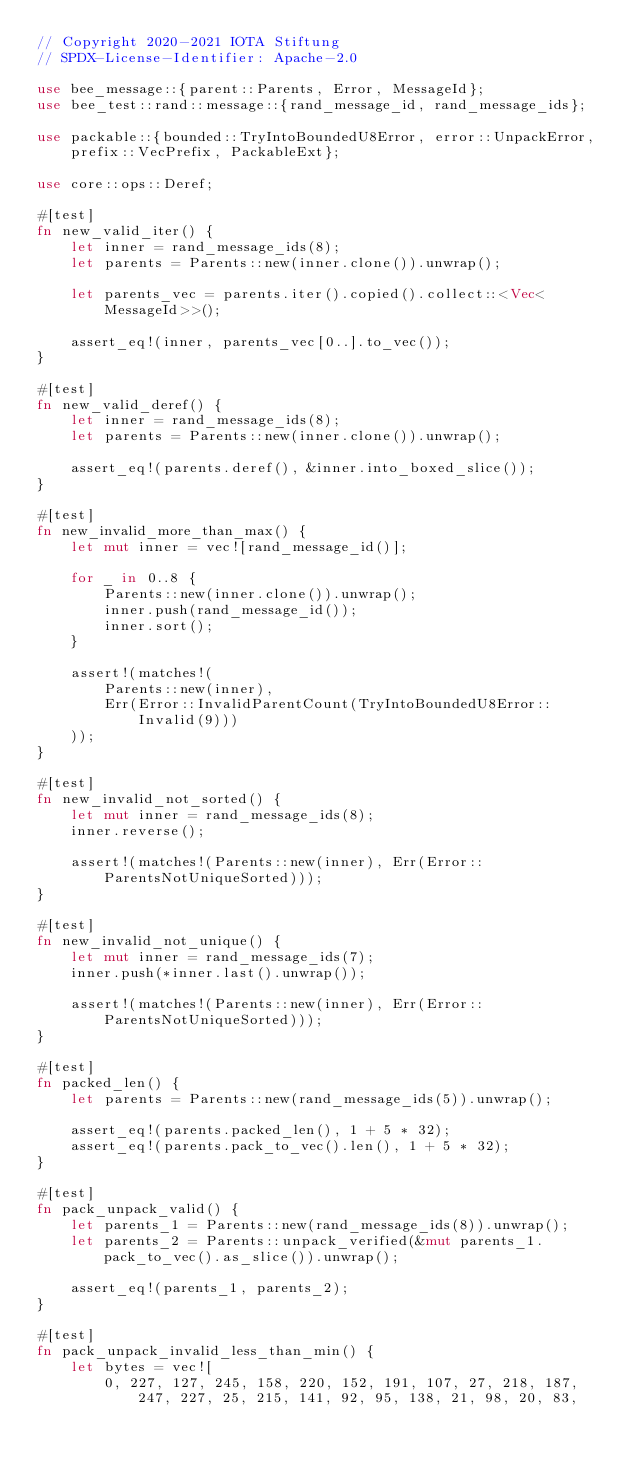<code> <loc_0><loc_0><loc_500><loc_500><_Rust_>// Copyright 2020-2021 IOTA Stiftung
// SPDX-License-Identifier: Apache-2.0

use bee_message::{parent::Parents, Error, MessageId};
use bee_test::rand::message::{rand_message_id, rand_message_ids};

use packable::{bounded::TryIntoBoundedU8Error, error::UnpackError, prefix::VecPrefix, PackableExt};

use core::ops::Deref;

#[test]
fn new_valid_iter() {
    let inner = rand_message_ids(8);
    let parents = Parents::new(inner.clone()).unwrap();

    let parents_vec = parents.iter().copied().collect::<Vec<MessageId>>();

    assert_eq!(inner, parents_vec[0..].to_vec());
}

#[test]
fn new_valid_deref() {
    let inner = rand_message_ids(8);
    let parents = Parents::new(inner.clone()).unwrap();

    assert_eq!(parents.deref(), &inner.into_boxed_slice());
}

#[test]
fn new_invalid_more_than_max() {
    let mut inner = vec![rand_message_id()];

    for _ in 0..8 {
        Parents::new(inner.clone()).unwrap();
        inner.push(rand_message_id());
        inner.sort();
    }

    assert!(matches!(
        Parents::new(inner),
        Err(Error::InvalidParentCount(TryIntoBoundedU8Error::Invalid(9)))
    ));
}

#[test]
fn new_invalid_not_sorted() {
    let mut inner = rand_message_ids(8);
    inner.reverse();

    assert!(matches!(Parents::new(inner), Err(Error::ParentsNotUniqueSorted)));
}

#[test]
fn new_invalid_not_unique() {
    let mut inner = rand_message_ids(7);
    inner.push(*inner.last().unwrap());

    assert!(matches!(Parents::new(inner), Err(Error::ParentsNotUniqueSorted)));
}

#[test]
fn packed_len() {
    let parents = Parents::new(rand_message_ids(5)).unwrap();

    assert_eq!(parents.packed_len(), 1 + 5 * 32);
    assert_eq!(parents.pack_to_vec().len(), 1 + 5 * 32);
}

#[test]
fn pack_unpack_valid() {
    let parents_1 = Parents::new(rand_message_ids(8)).unwrap();
    let parents_2 = Parents::unpack_verified(&mut parents_1.pack_to_vec().as_slice()).unwrap();

    assert_eq!(parents_1, parents_2);
}

#[test]
fn pack_unpack_invalid_less_than_min() {
    let bytes = vec![
        0, 227, 127, 245, 158, 220, 152, 191, 107, 27, 218, 187, 247, 227, 25, 215, 141, 92, 95, 138, 21, 98, 20, 83,</code> 